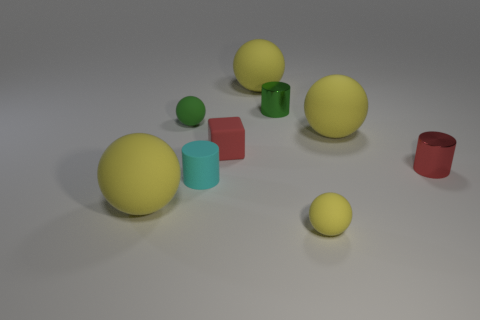Could you describe the colors and textures of the objects presented in the image? Certainly! The image showcases objects with both matte and glossy textures. There are two large yellow matte spheres, a smaller lime green matte sphere, and an even smaller yellow matte sphere. A glossy teal cylinder and a glossy green cup complement the matte textures. Among the geometric figures, a matte red cube stands out. How are the objects arranged spatially in relation to one another? The objects are arranged on a flat surface, with the smaller yellow sphere closer to the foreground. The two large yellow spheres are positioned further back, slightly to the left, and one is partially obscured by the other. The lime green sphere is in between the smaller and larger yellow spheres. The red cube, teal cylinder, and green cup are grouped more closely together on the right. 